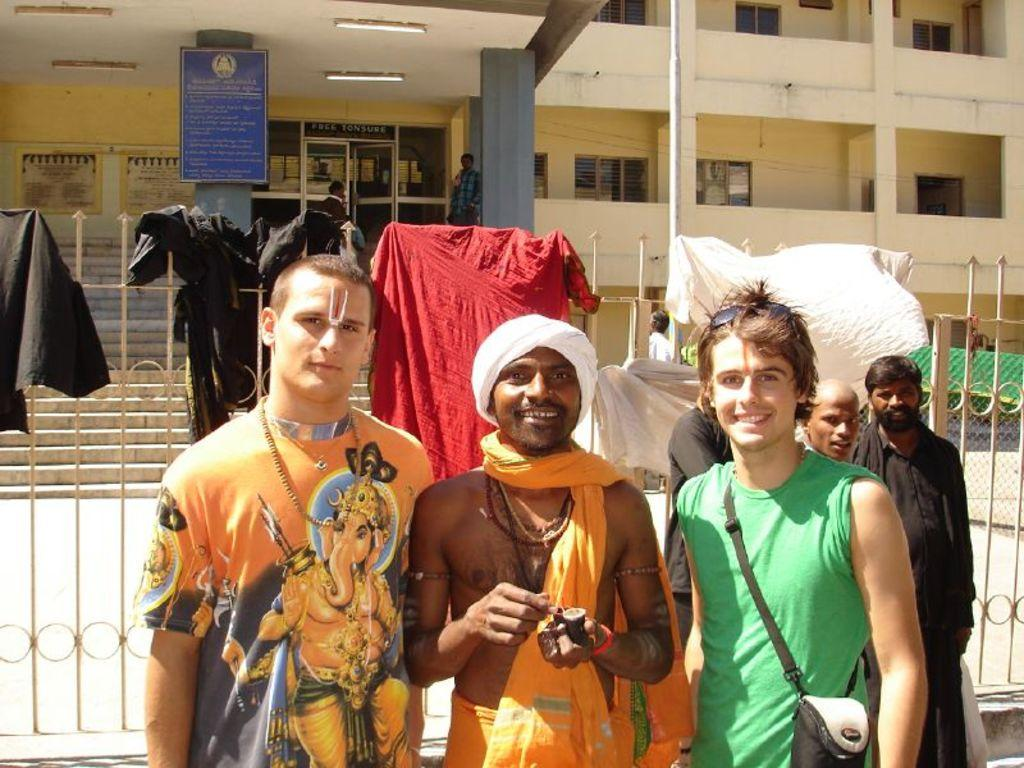Who or what can be seen in the image? There are people in the image. What can be seen in the distance behind the people? There is a fence, clothes, a building, and some objects in the background of the image. What type of dime can be seen in the image? There is no dime present in the image. What is the view like from the building in the background? The image does not provide a view from the building, as it only shows the people and the background details. 